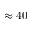<formula> <loc_0><loc_0><loc_500><loc_500>\approx 4 0</formula> 